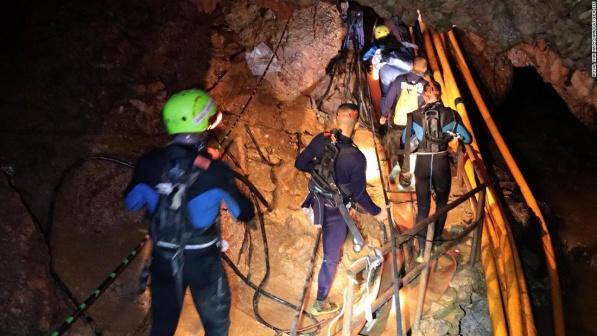Explain the visual content of the image in great detail. The image portrays a group of five adventurers navigating through a rugged, dimly lit cave. Each member of the group is equipped with a helmet featuring a headlamp, which is their primary source of light in the otherwise dark environment. They are wearing wetsuits and climbing gear suitable for cave exploration. The adventurers are tightly secured by ropes that offer stability and safety as they move along a metal rope ladder positioned against the rocky and uneven cave walls. The individual at the foreground is dressed in a blue and black wetsuit, with their green helmet contrasting against the dark backdrop. They appear to be leading the group as they ascend. Bright yellow pipes or cables run along the side of the path, adding a splash of color to the otherwise monochromatic landscape. There is a palpable sense of teamwork and determination as the group makes its way through this challenging subterranean environment, working together to explore and conquer the hidden depths of the cave. 